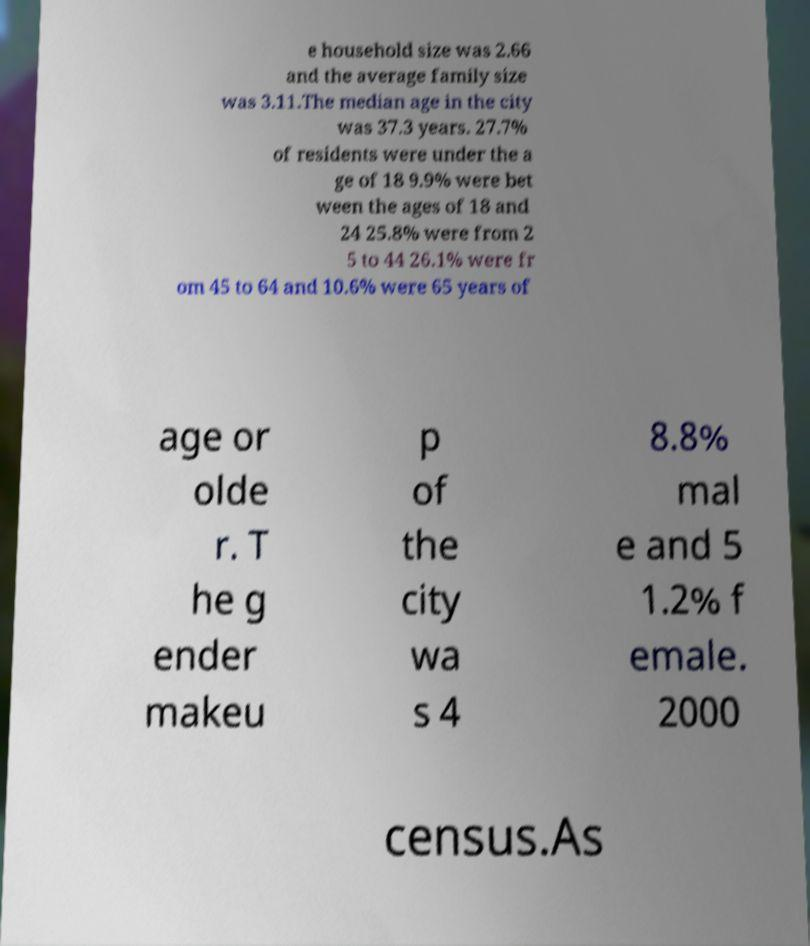Could you extract and type out the text from this image? e household size was 2.66 and the average family size was 3.11.The median age in the city was 37.3 years. 27.7% of residents were under the a ge of 18 9.9% were bet ween the ages of 18 and 24 25.8% were from 2 5 to 44 26.1% were fr om 45 to 64 and 10.6% were 65 years of age or olde r. T he g ender makeu p of the city wa s 4 8.8% mal e and 5 1.2% f emale. 2000 census.As 